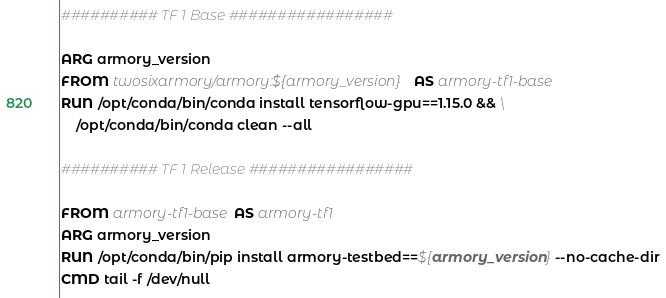<code> <loc_0><loc_0><loc_500><loc_500><_Dockerfile_>########## TF 1 Base #################

ARG armory_version
FROM twosixarmory/armory:${armory_version} AS armory-tf1-base
RUN /opt/conda/bin/conda install tensorflow-gpu==1.15.0 && \
    /opt/conda/bin/conda clean --all

########## TF 1 Release #################

FROM armory-tf1-base AS armory-tf1
ARG armory_version
RUN /opt/conda/bin/pip install armory-testbed==${armory_version} --no-cache-dir
CMD tail -f /dev/null
</code> 